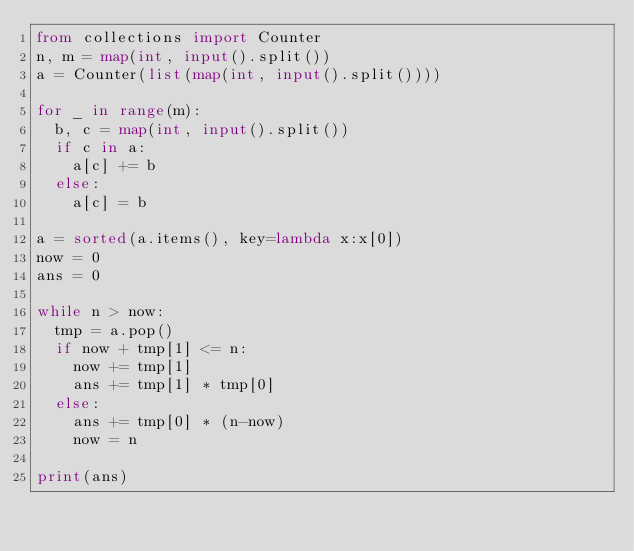Convert code to text. <code><loc_0><loc_0><loc_500><loc_500><_Python_>from collections import Counter
n, m = map(int, input().split())
a = Counter(list(map(int, input().split())))
 
for _ in range(m):
  b, c = map(int, input().split())
  if c in a:
    a[c] += b
  else:
    a[c] = b
 
a = sorted(a.items(), key=lambda x:x[0])
now = 0
ans = 0 
 
while n > now:
  tmp = a.pop()
  if now + tmp[1] <= n:
    now += tmp[1]
    ans += tmp[1] * tmp[0]
  else:
    ans += tmp[0] * (n-now)
    now = n
 
print(ans)</code> 